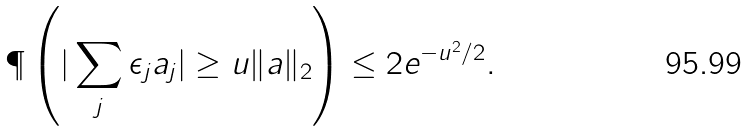Convert formula to latex. <formula><loc_0><loc_0><loc_500><loc_500>\P \left ( | \sum _ { j } \epsilon _ { j } a _ { j } | \geq u \| a \| _ { 2 } \right ) \leq 2 e ^ { - u ^ { 2 } / 2 } .</formula> 